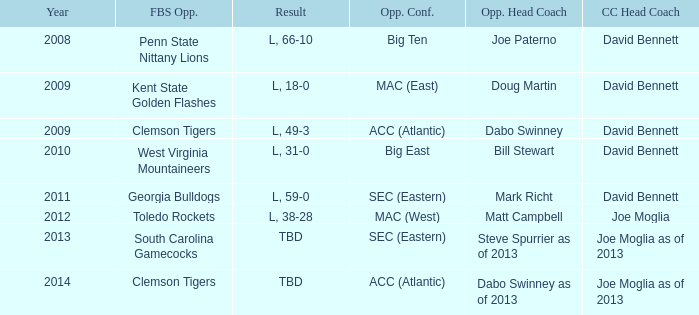What was the result when then opponents conference was Mac (east)? L, 18-0. 